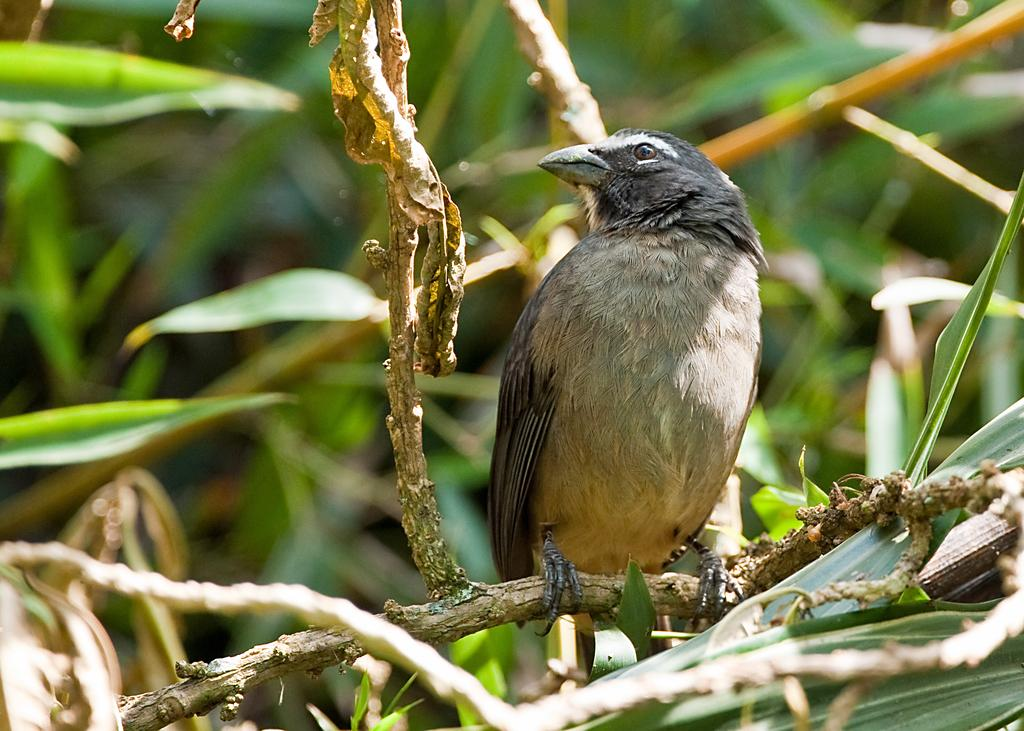What type of animal can be seen in the image? There is a bird in the image. Where is the bird located in the image? The bird is on the branch of a plant. What type of goat can be seen in the image? There is no goat present in the image; it features a bird on the branch of a plant. Is there any rain visible in the image? There is no rain present in the image. 